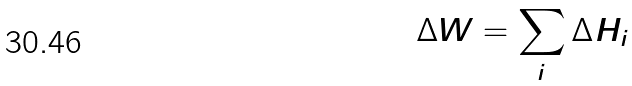Convert formula to latex. <formula><loc_0><loc_0><loc_500><loc_500>\Delta W = \sum _ { i } \Delta H _ { i }</formula> 